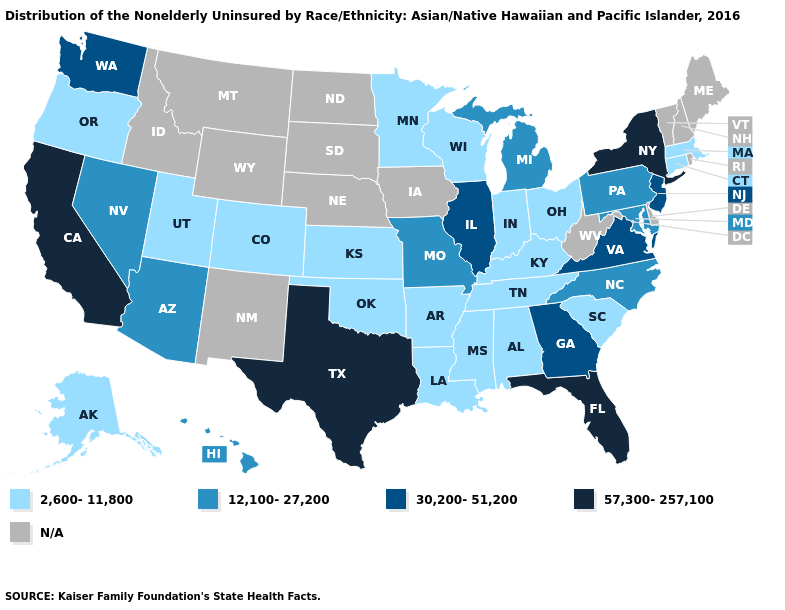Which states have the highest value in the USA?
Concise answer only. California, Florida, New York, Texas. Does Pennsylvania have the highest value in the Northeast?
Give a very brief answer. No. What is the lowest value in the Northeast?
Concise answer only. 2,600-11,800. Name the states that have a value in the range 30,200-51,200?
Concise answer only. Georgia, Illinois, New Jersey, Virginia, Washington. Name the states that have a value in the range 2,600-11,800?
Short answer required. Alabama, Alaska, Arkansas, Colorado, Connecticut, Indiana, Kansas, Kentucky, Louisiana, Massachusetts, Minnesota, Mississippi, Ohio, Oklahoma, Oregon, South Carolina, Tennessee, Utah, Wisconsin. What is the value of Nevada?
Short answer required. 12,100-27,200. Among the states that border Ohio , which have the highest value?
Be succinct. Michigan, Pennsylvania. What is the value of Nevada?
Concise answer only. 12,100-27,200. Does the map have missing data?
Answer briefly. Yes. What is the lowest value in states that border Nevada?
Short answer required. 2,600-11,800. Does the first symbol in the legend represent the smallest category?
Quick response, please. Yes. Does North Carolina have the lowest value in the South?
Give a very brief answer. No. Name the states that have a value in the range N/A?
Quick response, please. Delaware, Idaho, Iowa, Maine, Montana, Nebraska, New Hampshire, New Mexico, North Dakota, Rhode Island, South Dakota, Vermont, West Virginia, Wyoming. 